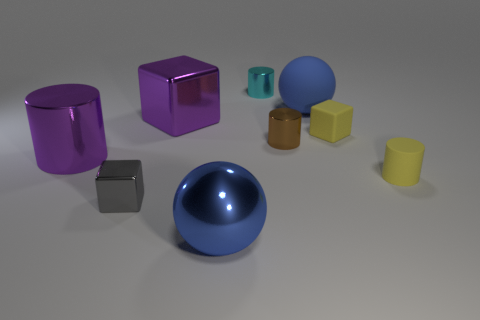Subtract all big cylinders. How many cylinders are left? 3 Subtract all cyan cylinders. How many cylinders are left? 3 Add 1 big purple metal cylinders. How many objects exist? 10 Subtract all gray cylinders. Subtract all blue cubes. How many cylinders are left? 4 Subtract all blocks. How many objects are left? 6 Subtract all gray metallic cubes. Subtract all gray shiny cubes. How many objects are left? 7 Add 6 brown shiny cylinders. How many brown shiny cylinders are left? 7 Add 4 tiny cylinders. How many tiny cylinders exist? 7 Subtract 0 green blocks. How many objects are left? 9 